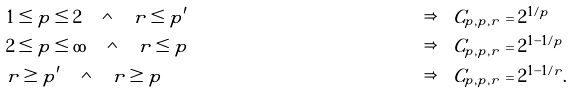<formula> <loc_0><loc_0><loc_500><loc_500>& 1 \leq p \leq 2 \quad \wedge \quad r \leq p ^ { \prime } & \Rightarrow \quad & C _ { p , p , r } = 2 ^ { 1 / p } \\ & 2 \leq p \leq \infty \quad \wedge \quad r \leq p & \Rightarrow \quad & C _ { p , p , r } = 2 ^ { 1 - 1 / p } \\ & r \geq p ^ { \prime } \quad \wedge \quad r \geq p & \Rightarrow \quad & C _ { p , p , r } = 2 ^ { 1 - 1 / r } .</formula> 